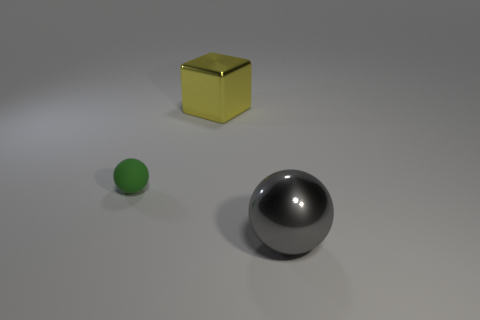Add 3 tiny yellow matte cylinders. How many objects exist? 6 Subtract all balls. How many objects are left? 1 Subtract all big gray metal things. Subtract all large red rubber blocks. How many objects are left? 2 Add 1 gray metallic objects. How many gray metallic objects are left? 2 Add 1 purple metal spheres. How many purple metal spheres exist? 1 Subtract 1 gray balls. How many objects are left? 2 